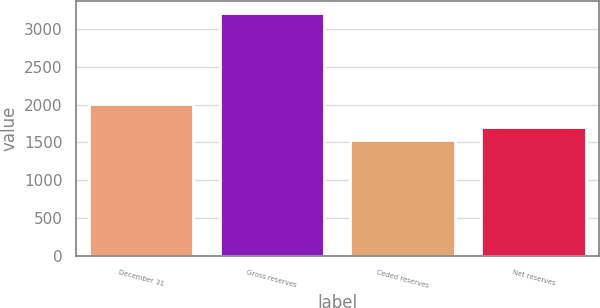Convert chart. <chart><loc_0><loc_0><loc_500><loc_500><bar_chart><fcel>December 31<fcel>Gross reserves<fcel>Ceded reserves<fcel>Net reserves<nl><fcel>2004<fcel>3218<fcel>1532<fcel>1700.6<nl></chart> 